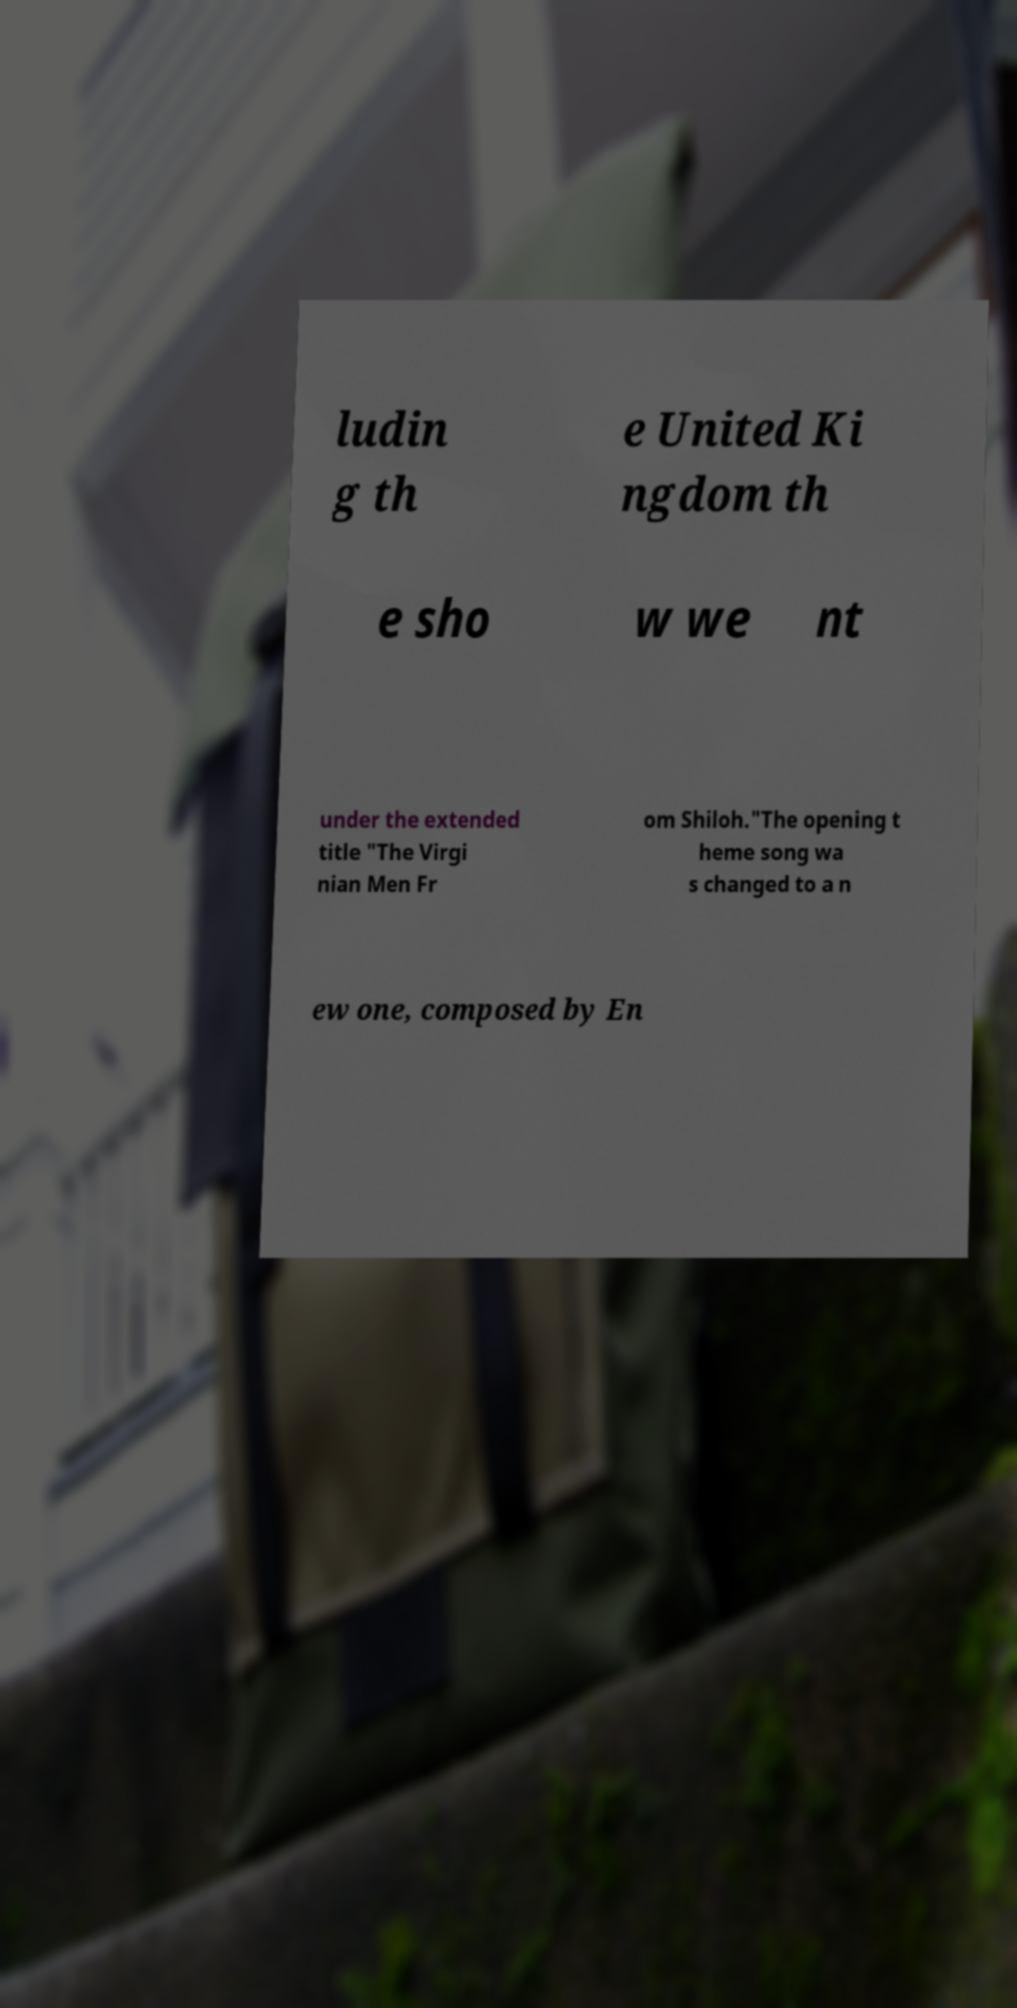What messages or text are displayed in this image? I need them in a readable, typed format. ludin g th e United Ki ngdom th e sho w we nt under the extended title "The Virgi nian Men Fr om Shiloh."The opening t heme song wa s changed to a n ew one, composed by En 